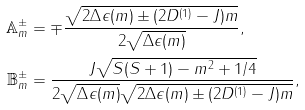<formula> <loc_0><loc_0><loc_500><loc_500>\mathbb { A } ^ { \pm } _ { m } & = \mp \frac { \sqrt { 2 \Delta \epsilon ( m ) \pm ( 2 D ^ { ( 1 ) } - J ) m } } { 2 \sqrt { \Delta \epsilon ( m ) } } , \\ \mathbb { B } ^ { \pm } _ { m } & = \frac { J \sqrt { S ( S + 1 ) - m ^ { 2 } + 1 / 4 } } { 2 \sqrt { \Delta \epsilon ( m ) } \sqrt { 2 \Delta \epsilon ( m ) \pm ( 2 D ^ { ( 1 ) } - J ) m } } ,</formula> 